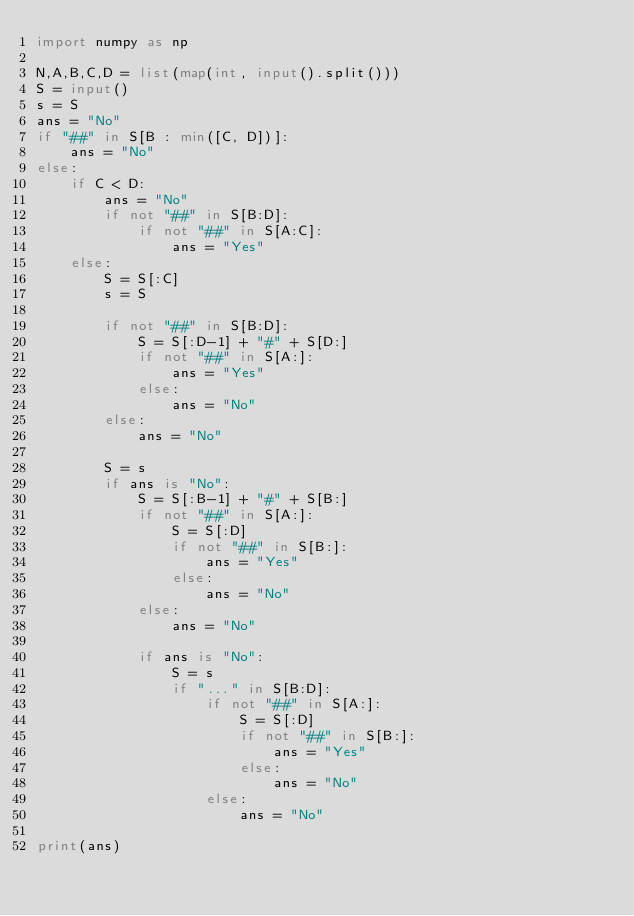Convert code to text. <code><loc_0><loc_0><loc_500><loc_500><_Python_>import numpy as np

N,A,B,C,D = list(map(int, input().split()))
S = input()
s = S
ans = "No"
if "##" in S[B : min([C, D])]:
    ans = "No"
else:
    if C < D:
        ans = "No"
        if not "##" in S[B:D]:
            if not "##" in S[A:C]:
                ans = "Yes"
    else:
        S = S[:C]
        s = S
        
        if not "##" in S[B:D]:
            S = S[:D-1] + "#" + S[D:]
            if not "##" in S[A:]:
                ans = "Yes"
            else:
                ans = "No"
        else:
            ans = "No"

        S = s
        if ans is "No":
            S = S[:B-1] + "#" + S[B:]
            if not "##" in S[A:]:
                S = S[:D]
                if not "##" in S[B:]:
                    ans = "Yes"
                else:
                    ans = "No"
            else:
                ans = "No"

            if ans is "No":
                S = s
                if "..." in S[B:D]:
                    if not "##" in S[A:]:
                        S = S[:D]
                        if not "##" in S[B:]:
                            ans = "Yes"
                        else:
                            ans = "No"
                    else:
                        ans = "No"        

print(ans)</code> 